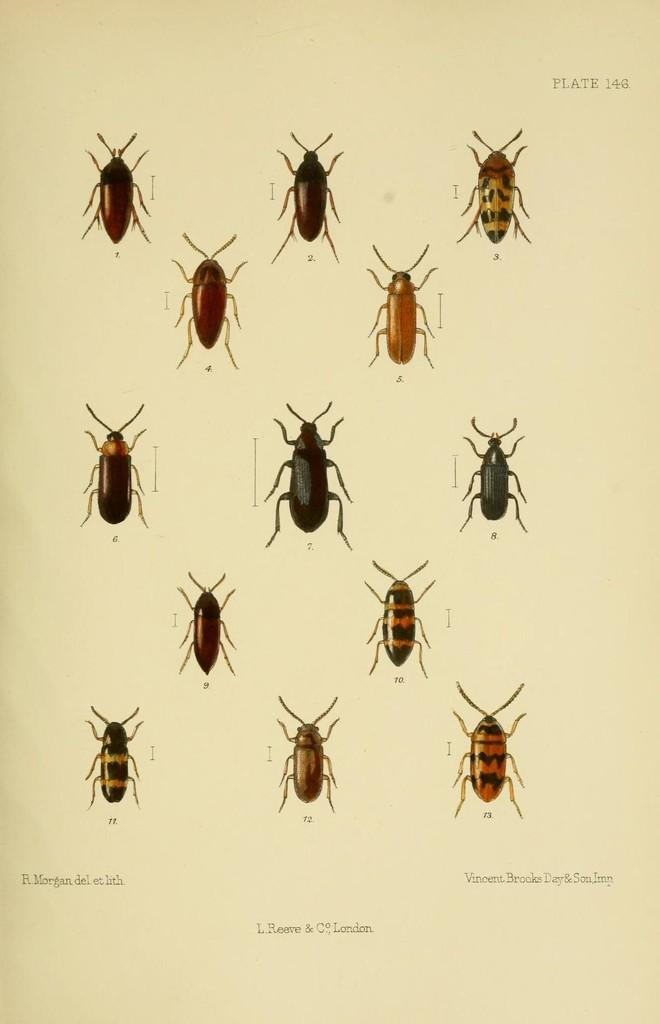What is present in the image that is related to writing or reading? There is a paper in the image that contains text and images of insects. What type of content is on the paper? The paper contains different types of insects. Can you describe the text on the paper? The text on the paper is not specified in the facts, but it is present. Where is the pocket located in the image? There is no pocket present in the image. What type of laborer is depicted in the image? There is no laborer depicted in the image; it features a paper with text and images of insects. 